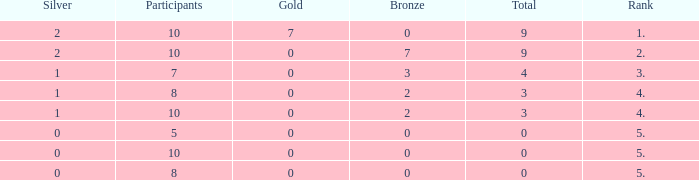What is the total number of Participants that has Silver that's smaller than 0? None. 